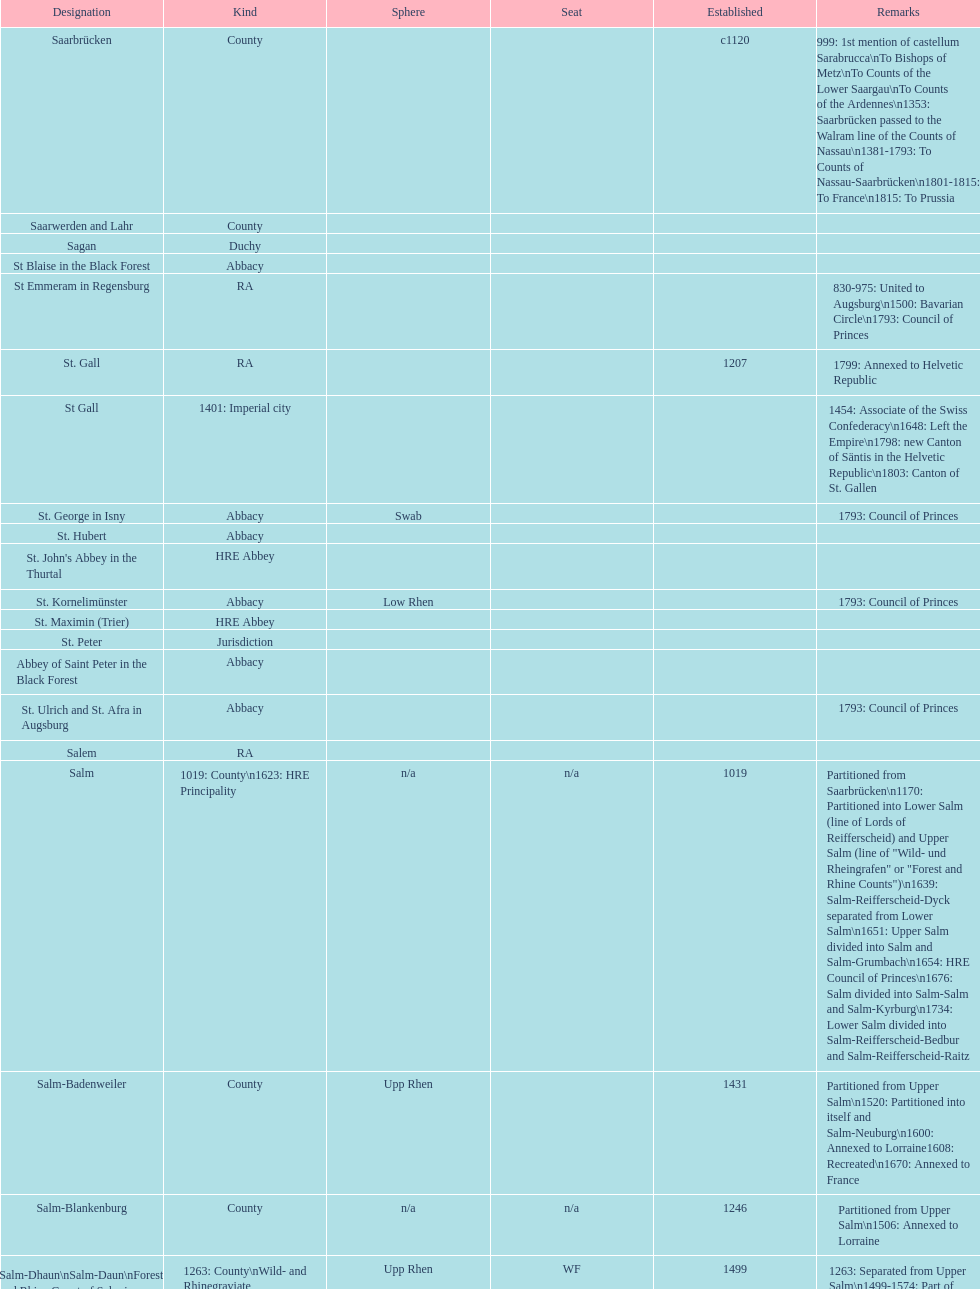How many states were of the same type as stuhlingen? 3. 